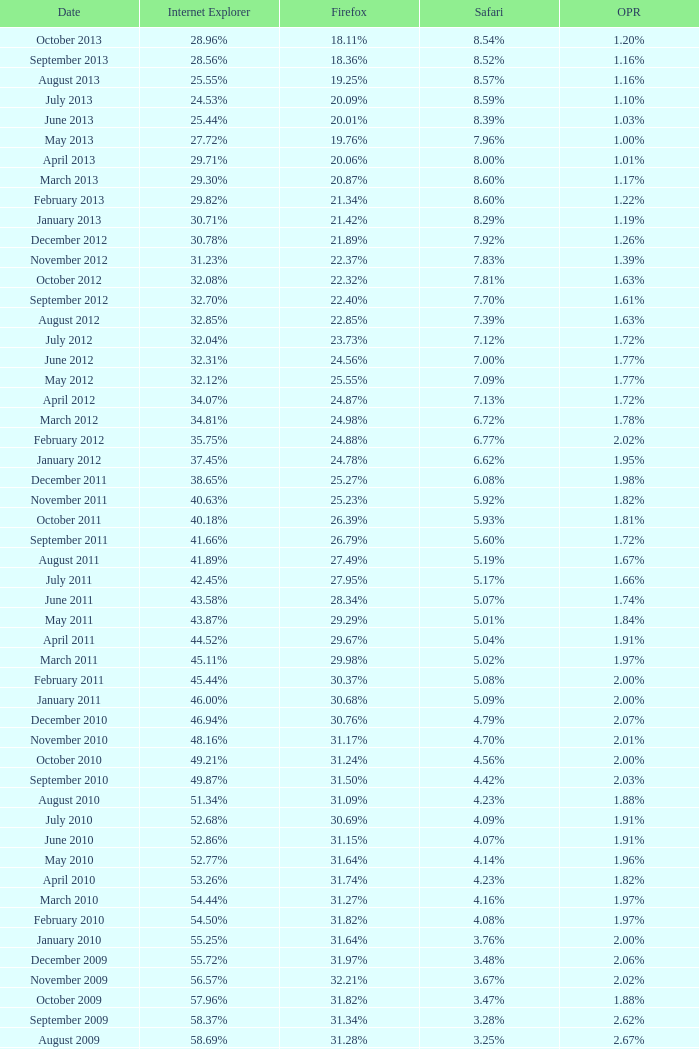What percentage of browsers were using Internet Explorer in April 2009? 61.88%. Could you parse the entire table as a dict? {'header': ['Date', 'Internet Explorer', 'Firefox', 'Safari', 'OPR'], 'rows': [['October 2013', '28.96%', '18.11%', '8.54%', '1.20%'], ['September 2013', '28.56%', '18.36%', '8.52%', '1.16%'], ['August 2013', '25.55%', '19.25%', '8.57%', '1.16%'], ['July 2013', '24.53%', '20.09%', '8.59%', '1.10%'], ['June 2013', '25.44%', '20.01%', '8.39%', '1.03%'], ['May 2013', '27.72%', '19.76%', '7.96%', '1.00%'], ['April 2013', '29.71%', '20.06%', '8.00%', '1.01%'], ['March 2013', '29.30%', '20.87%', '8.60%', '1.17%'], ['February 2013', '29.82%', '21.34%', '8.60%', '1.22%'], ['January 2013', '30.71%', '21.42%', '8.29%', '1.19%'], ['December 2012', '30.78%', '21.89%', '7.92%', '1.26%'], ['November 2012', '31.23%', '22.37%', '7.83%', '1.39%'], ['October 2012', '32.08%', '22.32%', '7.81%', '1.63%'], ['September 2012', '32.70%', '22.40%', '7.70%', '1.61%'], ['August 2012', '32.85%', '22.85%', '7.39%', '1.63%'], ['July 2012', '32.04%', '23.73%', '7.12%', '1.72%'], ['June 2012', '32.31%', '24.56%', '7.00%', '1.77%'], ['May 2012', '32.12%', '25.55%', '7.09%', '1.77%'], ['April 2012', '34.07%', '24.87%', '7.13%', '1.72%'], ['March 2012', '34.81%', '24.98%', '6.72%', '1.78%'], ['February 2012', '35.75%', '24.88%', '6.77%', '2.02%'], ['January 2012', '37.45%', '24.78%', '6.62%', '1.95%'], ['December 2011', '38.65%', '25.27%', '6.08%', '1.98%'], ['November 2011', '40.63%', '25.23%', '5.92%', '1.82%'], ['October 2011', '40.18%', '26.39%', '5.93%', '1.81%'], ['September 2011', '41.66%', '26.79%', '5.60%', '1.72%'], ['August 2011', '41.89%', '27.49%', '5.19%', '1.67%'], ['July 2011', '42.45%', '27.95%', '5.17%', '1.66%'], ['June 2011', '43.58%', '28.34%', '5.07%', '1.74%'], ['May 2011', '43.87%', '29.29%', '5.01%', '1.84%'], ['April 2011', '44.52%', '29.67%', '5.04%', '1.91%'], ['March 2011', '45.11%', '29.98%', '5.02%', '1.97%'], ['February 2011', '45.44%', '30.37%', '5.08%', '2.00%'], ['January 2011', '46.00%', '30.68%', '5.09%', '2.00%'], ['December 2010', '46.94%', '30.76%', '4.79%', '2.07%'], ['November 2010', '48.16%', '31.17%', '4.70%', '2.01%'], ['October 2010', '49.21%', '31.24%', '4.56%', '2.00%'], ['September 2010', '49.87%', '31.50%', '4.42%', '2.03%'], ['August 2010', '51.34%', '31.09%', '4.23%', '1.88%'], ['July 2010', '52.68%', '30.69%', '4.09%', '1.91%'], ['June 2010', '52.86%', '31.15%', '4.07%', '1.91%'], ['May 2010', '52.77%', '31.64%', '4.14%', '1.96%'], ['April 2010', '53.26%', '31.74%', '4.23%', '1.82%'], ['March 2010', '54.44%', '31.27%', '4.16%', '1.97%'], ['February 2010', '54.50%', '31.82%', '4.08%', '1.97%'], ['January 2010', '55.25%', '31.64%', '3.76%', '2.00%'], ['December 2009', '55.72%', '31.97%', '3.48%', '2.06%'], ['November 2009', '56.57%', '32.21%', '3.67%', '2.02%'], ['October 2009', '57.96%', '31.82%', '3.47%', '1.88%'], ['September 2009', '58.37%', '31.34%', '3.28%', '2.62%'], ['August 2009', '58.69%', '31.28%', '3.25%', '2.67%'], ['July 2009', '60.11%', '30.50%', '3.02%', '2.64%'], ['June 2009', '59.49%', '30.26%', '2.91%', '3.46%'], ['May 2009', '62.09%', '28.75%', '2.65%', '3.23%'], ['April 2009', '61.88%', '29.67%', '2.75%', '2.96%'], ['March 2009', '62.52%', '29.40%', '2.73%', '2.94%'], ['February 2009', '64.43%', '27.85%', '2.59%', '2.95%'], ['January 2009', '65.41%', '27.03%', '2.57%', '2.92%'], ['December 2008', '67.84%', '25.23%', '2.41%', '2.83%'], ['November 2008', '68.14%', '25.27%', '2.49%', '3.01%'], ['October 2008', '67.68%', '25.54%', '2.91%', '2.69%'], ['September2008', '67.16%', '25.77%', '3.00%', '2.86%'], ['August 2008', '68.91%', '26.08%', '2.99%', '1.83%'], ['July 2008', '68.57%', '26.14%', '3.30%', '1.78%']]} 